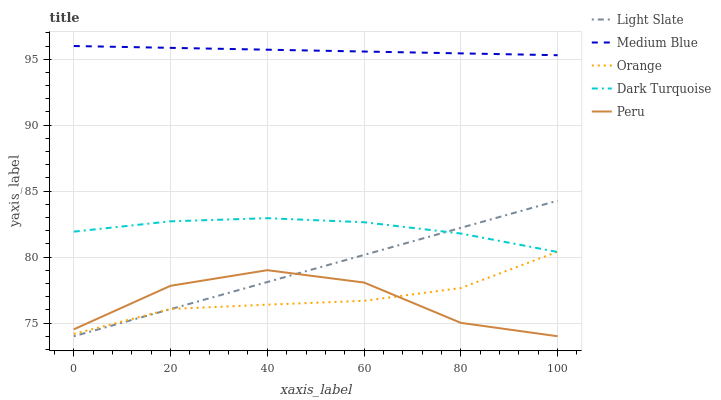Does Orange have the minimum area under the curve?
Answer yes or no. Yes. Does Medium Blue have the maximum area under the curve?
Answer yes or no. Yes. Does Medium Blue have the minimum area under the curve?
Answer yes or no. No. Does Orange have the maximum area under the curve?
Answer yes or no. No. Is Light Slate the smoothest?
Answer yes or no. Yes. Is Peru the roughest?
Answer yes or no. Yes. Is Orange the smoothest?
Answer yes or no. No. Is Orange the roughest?
Answer yes or no. No. Does Light Slate have the lowest value?
Answer yes or no. Yes. Does Orange have the lowest value?
Answer yes or no. No. Does Medium Blue have the highest value?
Answer yes or no. Yes. Does Orange have the highest value?
Answer yes or no. No. Is Light Slate less than Medium Blue?
Answer yes or no. Yes. Is Dark Turquoise greater than Peru?
Answer yes or no. Yes. Does Orange intersect Peru?
Answer yes or no. Yes. Is Orange less than Peru?
Answer yes or no. No. Is Orange greater than Peru?
Answer yes or no. No. Does Light Slate intersect Medium Blue?
Answer yes or no. No. 